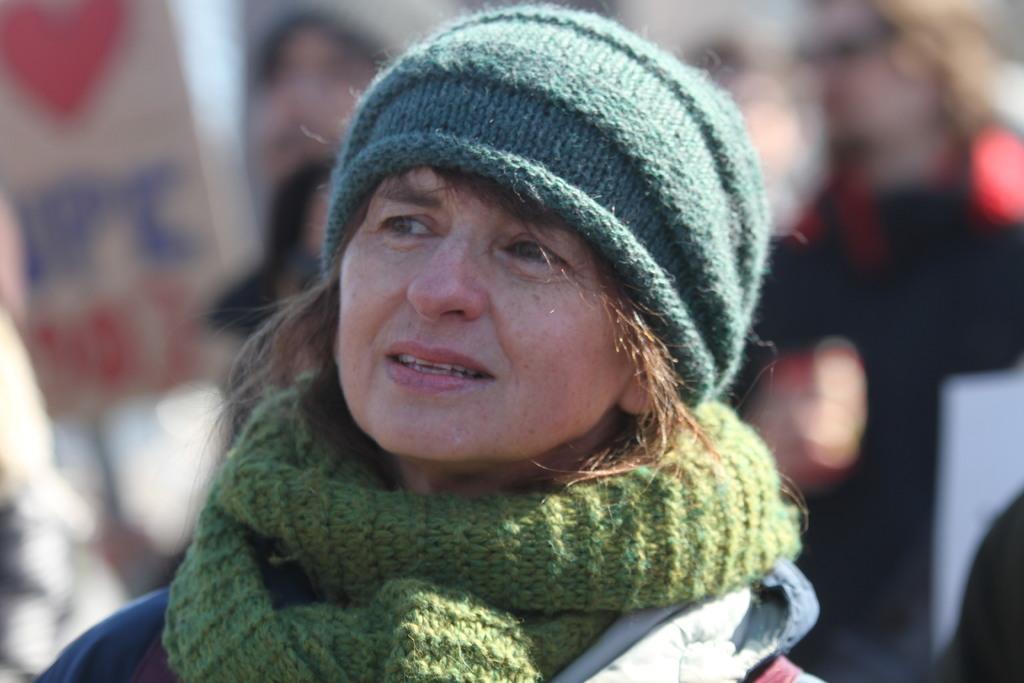In one or two sentences, can you explain what this image depicts? In this image I can see a woman wearing blue colored hat and green colored scarf and I can see the blurry background in which I can see few people. 